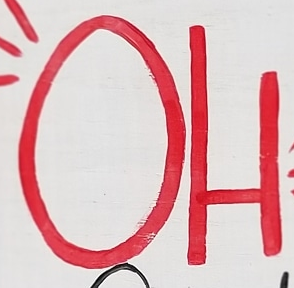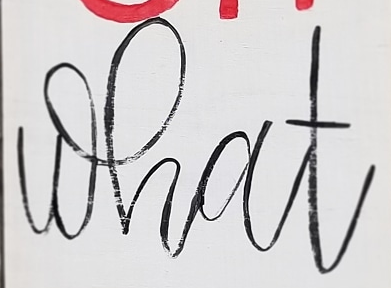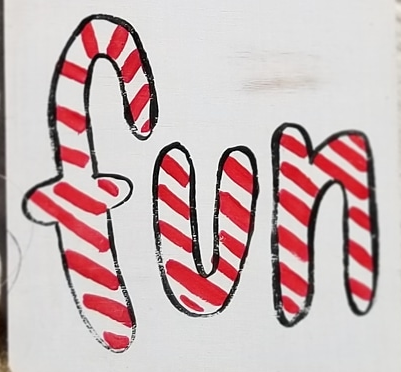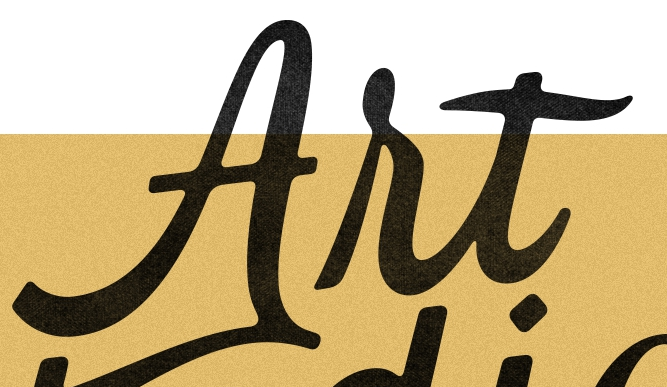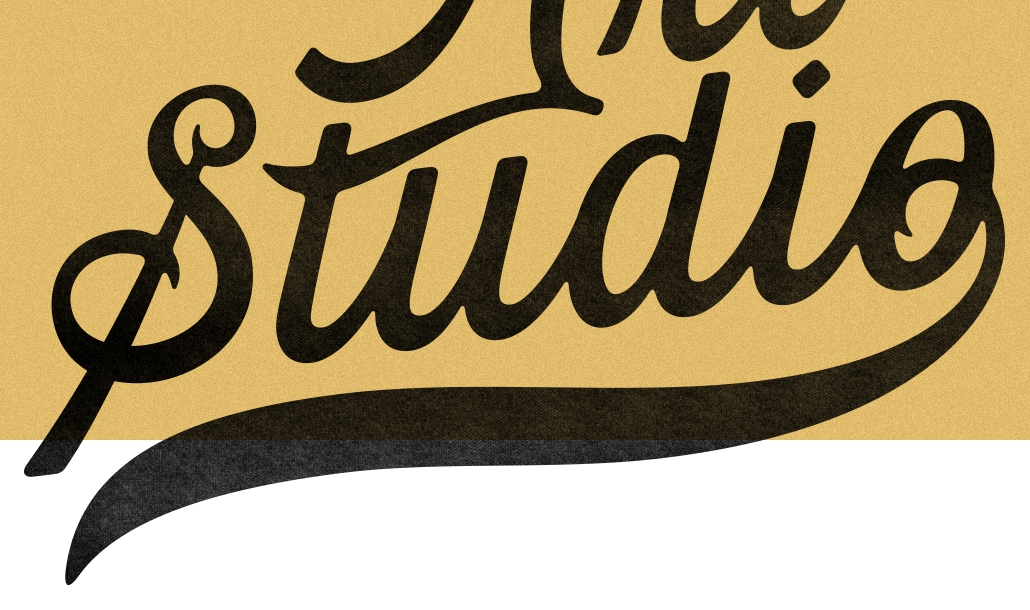Transcribe the words shown in these images in order, separated by a semicolon. OH; what; fun; Art; Studio 